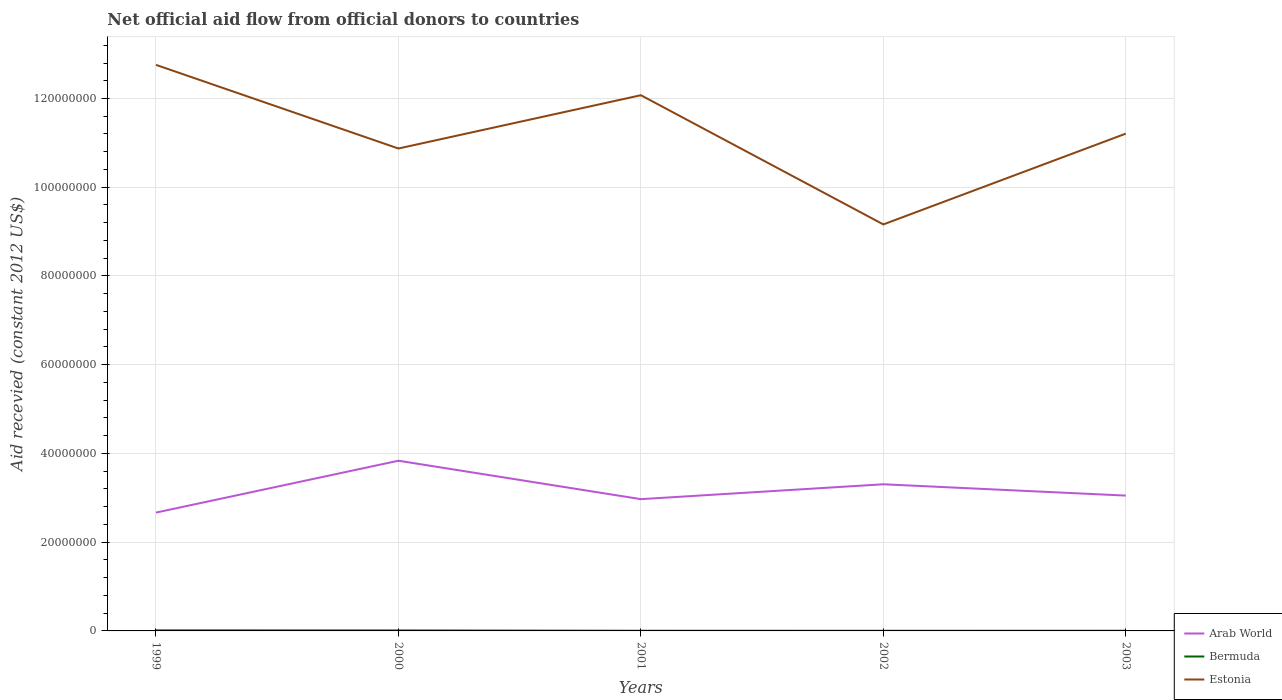Does the line corresponding to Estonia intersect with the line corresponding to Arab World?
Your answer should be very brief. No. Across all years, what is the maximum total aid received in Estonia?
Your answer should be compact. 9.16e+07. In which year was the total aid received in Bermuda maximum?
Offer a terse response. 2002. What is the total total aid received in Estonia in the graph?
Offer a terse response. 2.91e+07. What is the difference between the highest and the second highest total aid received in Estonia?
Offer a terse response. 3.60e+07. Is the total aid received in Arab World strictly greater than the total aid received in Estonia over the years?
Make the answer very short. Yes. How many lines are there?
Offer a very short reply. 3. How many years are there in the graph?
Give a very brief answer. 5. What is the difference between two consecutive major ticks on the Y-axis?
Give a very brief answer. 2.00e+07. Does the graph contain any zero values?
Offer a terse response. No. Does the graph contain grids?
Give a very brief answer. Yes. Where does the legend appear in the graph?
Keep it short and to the point. Bottom right. How many legend labels are there?
Give a very brief answer. 3. What is the title of the graph?
Your answer should be compact. Net official aid flow from official donors to countries. What is the label or title of the X-axis?
Your answer should be compact. Years. What is the label or title of the Y-axis?
Your response must be concise. Aid recevied (constant 2012 US$). What is the Aid recevied (constant 2012 US$) in Arab World in 1999?
Keep it short and to the point. 2.67e+07. What is the Aid recevied (constant 2012 US$) in Bermuda in 1999?
Offer a terse response. 1.30e+05. What is the Aid recevied (constant 2012 US$) in Estonia in 1999?
Offer a very short reply. 1.28e+08. What is the Aid recevied (constant 2012 US$) in Arab World in 2000?
Provide a succinct answer. 3.84e+07. What is the Aid recevied (constant 2012 US$) of Bermuda in 2000?
Make the answer very short. 1.10e+05. What is the Aid recevied (constant 2012 US$) in Estonia in 2000?
Your answer should be compact. 1.09e+08. What is the Aid recevied (constant 2012 US$) in Arab World in 2001?
Offer a terse response. 2.97e+07. What is the Aid recevied (constant 2012 US$) of Bermuda in 2001?
Provide a succinct answer. 4.00e+04. What is the Aid recevied (constant 2012 US$) in Estonia in 2001?
Ensure brevity in your answer.  1.21e+08. What is the Aid recevied (constant 2012 US$) of Arab World in 2002?
Offer a terse response. 3.30e+07. What is the Aid recevied (constant 2012 US$) of Estonia in 2002?
Your response must be concise. 9.16e+07. What is the Aid recevied (constant 2012 US$) in Arab World in 2003?
Provide a short and direct response. 3.05e+07. What is the Aid recevied (constant 2012 US$) of Bermuda in 2003?
Give a very brief answer. 4.00e+04. What is the Aid recevied (constant 2012 US$) in Estonia in 2003?
Provide a short and direct response. 1.12e+08. Across all years, what is the maximum Aid recevied (constant 2012 US$) of Arab World?
Provide a succinct answer. 3.84e+07. Across all years, what is the maximum Aid recevied (constant 2012 US$) in Estonia?
Keep it short and to the point. 1.28e+08. Across all years, what is the minimum Aid recevied (constant 2012 US$) of Arab World?
Ensure brevity in your answer.  2.67e+07. Across all years, what is the minimum Aid recevied (constant 2012 US$) in Bermuda?
Your response must be concise. 3.00e+04. Across all years, what is the minimum Aid recevied (constant 2012 US$) of Estonia?
Make the answer very short. 9.16e+07. What is the total Aid recevied (constant 2012 US$) of Arab World in the graph?
Keep it short and to the point. 1.58e+08. What is the total Aid recevied (constant 2012 US$) of Bermuda in the graph?
Ensure brevity in your answer.  3.50e+05. What is the total Aid recevied (constant 2012 US$) in Estonia in the graph?
Offer a terse response. 5.61e+08. What is the difference between the Aid recevied (constant 2012 US$) in Arab World in 1999 and that in 2000?
Provide a succinct answer. -1.17e+07. What is the difference between the Aid recevied (constant 2012 US$) of Bermuda in 1999 and that in 2000?
Give a very brief answer. 2.00e+04. What is the difference between the Aid recevied (constant 2012 US$) in Estonia in 1999 and that in 2000?
Your response must be concise. 1.88e+07. What is the difference between the Aid recevied (constant 2012 US$) of Arab World in 1999 and that in 2001?
Provide a short and direct response. -3.03e+06. What is the difference between the Aid recevied (constant 2012 US$) in Estonia in 1999 and that in 2001?
Ensure brevity in your answer.  6.84e+06. What is the difference between the Aid recevied (constant 2012 US$) of Arab World in 1999 and that in 2002?
Provide a short and direct response. -6.38e+06. What is the difference between the Aid recevied (constant 2012 US$) in Estonia in 1999 and that in 2002?
Offer a terse response. 3.60e+07. What is the difference between the Aid recevied (constant 2012 US$) of Arab World in 1999 and that in 2003?
Keep it short and to the point. -3.83e+06. What is the difference between the Aid recevied (constant 2012 US$) in Estonia in 1999 and that in 2003?
Offer a very short reply. 1.55e+07. What is the difference between the Aid recevied (constant 2012 US$) of Arab World in 2000 and that in 2001?
Ensure brevity in your answer.  8.66e+06. What is the difference between the Aid recevied (constant 2012 US$) of Estonia in 2000 and that in 2001?
Your response must be concise. -1.20e+07. What is the difference between the Aid recevied (constant 2012 US$) of Arab World in 2000 and that in 2002?
Provide a succinct answer. 5.31e+06. What is the difference between the Aid recevied (constant 2012 US$) in Bermuda in 2000 and that in 2002?
Provide a succinct answer. 8.00e+04. What is the difference between the Aid recevied (constant 2012 US$) of Estonia in 2000 and that in 2002?
Your answer should be compact. 1.71e+07. What is the difference between the Aid recevied (constant 2012 US$) of Arab World in 2000 and that in 2003?
Ensure brevity in your answer.  7.86e+06. What is the difference between the Aid recevied (constant 2012 US$) of Bermuda in 2000 and that in 2003?
Provide a short and direct response. 7.00e+04. What is the difference between the Aid recevied (constant 2012 US$) in Estonia in 2000 and that in 2003?
Provide a succinct answer. -3.35e+06. What is the difference between the Aid recevied (constant 2012 US$) in Arab World in 2001 and that in 2002?
Give a very brief answer. -3.35e+06. What is the difference between the Aid recevied (constant 2012 US$) of Estonia in 2001 and that in 2002?
Provide a succinct answer. 2.91e+07. What is the difference between the Aid recevied (constant 2012 US$) of Arab World in 2001 and that in 2003?
Give a very brief answer. -8.00e+05. What is the difference between the Aid recevied (constant 2012 US$) of Estonia in 2001 and that in 2003?
Offer a terse response. 8.66e+06. What is the difference between the Aid recevied (constant 2012 US$) in Arab World in 2002 and that in 2003?
Give a very brief answer. 2.55e+06. What is the difference between the Aid recevied (constant 2012 US$) of Bermuda in 2002 and that in 2003?
Give a very brief answer. -10000. What is the difference between the Aid recevied (constant 2012 US$) of Estonia in 2002 and that in 2003?
Your answer should be compact. -2.05e+07. What is the difference between the Aid recevied (constant 2012 US$) in Arab World in 1999 and the Aid recevied (constant 2012 US$) in Bermuda in 2000?
Make the answer very short. 2.66e+07. What is the difference between the Aid recevied (constant 2012 US$) in Arab World in 1999 and the Aid recevied (constant 2012 US$) in Estonia in 2000?
Provide a short and direct response. -8.21e+07. What is the difference between the Aid recevied (constant 2012 US$) of Bermuda in 1999 and the Aid recevied (constant 2012 US$) of Estonia in 2000?
Make the answer very short. -1.09e+08. What is the difference between the Aid recevied (constant 2012 US$) of Arab World in 1999 and the Aid recevied (constant 2012 US$) of Bermuda in 2001?
Your response must be concise. 2.66e+07. What is the difference between the Aid recevied (constant 2012 US$) in Arab World in 1999 and the Aid recevied (constant 2012 US$) in Estonia in 2001?
Make the answer very short. -9.41e+07. What is the difference between the Aid recevied (constant 2012 US$) in Bermuda in 1999 and the Aid recevied (constant 2012 US$) in Estonia in 2001?
Your answer should be compact. -1.21e+08. What is the difference between the Aid recevied (constant 2012 US$) in Arab World in 1999 and the Aid recevied (constant 2012 US$) in Bermuda in 2002?
Provide a short and direct response. 2.66e+07. What is the difference between the Aid recevied (constant 2012 US$) in Arab World in 1999 and the Aid recevied (constant 2012 US$) in Estonia in 2002?
Your answer should be compact. -6.50e+07. What is the difference between the Aid recevied (constant 2012 US$) in Bermuda in 1999 and the Aid recevied (constant 2012 US$) in Estonia in 2002?
Offer a very short reply. -9.15e+07. What is the difference between the Aid recevied (constant 2012 US$) of Arab World in 1999 and the Aid recevied (constant 2012 US$) of Bermuda in 2003?
Offer a terse response. 2.66e+07. What is the difference between the Aid recevied (constant 2012 US$) of Arab World in 1999 and the Aid recevied (constant 2012 US$) of Estonia in 2003?
Keep it short and to the point. -8.54e+07. What is the difference between the Aid recevied (constant 2012 US$) of Bermuda in 1999 and the Aid recevied (constant 2012 US$) of Estonia in 2003?
Make the answer very short. -1.12e+08. What is the difference between the Aid recevied (constant 2012 US$) of Arab World in 2000 and the Aid recevied (constant 2012 US$) of Bermuda in 2001?
Your answer should be very brief. 3.83e+07. What is the difference between the Aid recevied (constant 2012 US$) of Arab World in 2000 and the Aid recevied (constant 2012 US$) of Estonia in 2001?
Your response must be concise. -8.24e+07. What is the difference between the Aid recevied (constant 2012 US$) in Bermuda in 2000 and the Aid recevied (constant 2012 US$) in Estonia in 2001?
Make the answer very short. -1.21e+08. What is the difference between the Aid recevied (constant 2012 US$) of Arab World in 2000 and the Aid recevied (constant 2012 US$) of Bermuda in 2002?
Give a very brief answer. 3.83e+07. What is the difference between the Aid recevied (constant 2012 US$) of Arab World in 2000 and the Aid recevied (constant 2012 US$) of Estonia in 2002?
Make the answer very short. -5.33e+07. What is the difference between the Aid recevied (constant 2012 US$) of Bermuda in 2000 and the Aid recevied (constant 2012 US$) of Estonia in 2002?
Keep it short and to the point. -9.15e+07. What is the difference between the Aid recevied (constant 2012 US$) in Arab World in 2000 and the Aid recevied (constant 2012 US$) in Bermuda in 2003?
Your answer should be very brief. 3.83e+07. What is the difference between the Aid recevied (constant 2012 US$) in Arab World in 2000 and the Aid recevied (constant 2012 US$) in Estonia in 2003?
Provide a succinct answer. -7.37e+07. What is the difference between the Aid recevied (constant 2012 US$) in Bermuda in 2000 and the Aid recevied (constant 2012 US$) in Estonia in 2003?
Ensure brevity in your answer.  -1.12e+08. What is the difference between the Aid recevied (constant 2012 US$) of Arab World in 2001 and the Aid recevied (constant 2012 US$) of Bermuda in 2002?
Give a very brief answer. 2.97e+07. What is the difference between the Aid recevied (constant 2012 US$) in Arab World in 2001 and the Aid recevied (constant 2012 US$) in Estonia in 2002?
Offer a very short reply. -6.19e+07. What is the difference between the Aid recevied (constant 2012 US$) of Bermuda in 2001 and the Aid recevied (constant 2012 US$) of Estonia in 2002?
Give a very brief answer. -9.16e+07. What is the difference between the Aid recevied (constant 2012 US$) in Arab World in 2001 and the Aid recevied (constant 2012 US$) in Bermuda in 2003?
Give a very brief answer. 2.97e+07. What is the difference between the Aid recevied (constant 2012 US$) in Arab World in 2001 and the Aid recevied (constant 2012 US$) in Estonia in 2003?
Keep it short and to the point. -8.24e+07. What is the difference between the Aid recevied (constant 2012 US$) in Bermuda in 2001 and the Aid recevied (constant 2012 US$) in Estonia in 2003?
Your answer should be very brief. -1.12e+08. What is the difference between the Aid recevied (constant 2012 US$) in Arab World in 2002 and the Aid recevied (constant 2012 US$) in Bermuda in 2003?
Provide a short and direct response. 3.30e+07. What is the difference between the Aid recevied (constant 2012 US$) of Arab World in 2002 and the Aid recevied (constant 2012 US$) of Estonia in 2003?
Provide a short and direct response. -7.90e+07. What is the difference between the Aid recevied (constant 2012 US$) in Bermuda in 2002 and the Aid recevied (constant 2012 US$) in Estonia in 2003?
Offer a very short reply. -1.12e+08. What is the average Aid recevied (constant 2012 US$) of Arab World per year?
Ensure brevity in your answer.  3.17e+07. What is the average Aid recevied (constant 2012 US$) of Estonia per year?
Offer a terse response. 1.12e+08. In the year 1999, what is the difference between the Aid recevied (constant 2012 US$) in Arab World and Aid recevied (constant 2012 US$) in Bermuda?
Offer a terse response. 2.65e+07. In the year 1999, what is the difference between the Aid recevied (constant 2012 US$) of Arab World and Aid recevied (constant 2012 US$) of Estonia?
Offer a terse response. -1.01e+08. In the year 1999, what is the difference between the Aid recevied (constant 2012 US$) of Bermuda and Aid recevied (constant 2012 US$) of Estonia?
Keep it short and to the point. -1.27e+08. In the year 2000, what is the difference between the Aid recevied (constant 2012 US$) in Arab World and Aid recevied (constant 2012 US$) in Bermuda?
Offer a very short reply. 3.82e+07. In the year 2000, what is the difference between the Aid recevied (constant 2012 US$) in Arab World and Aid recevied (constant 2012 US$) in Estonia?
Keep it short and to the point. -7.04e+07. In the year 2000, what is the difference between the Aid recevied (constant 2012 US$) of Bermuda and Aid recevied (constant 2012 US$) of Estonia?
Ensure brevity in your answer.  -1.09e+08. In the year 2001, what is the difference between the Aid recevied (constant 2012 US$) of Arab World and Aid recevied (constant 2012 US$) of Bermuda?
Your answer should be very brief. 2.97e+07. In the year 2001, what is the difference between the Aid recevied (constant 2012 US$) of Arab World and Aid recevied (constant 2012 US$) of Estonia?
Ensure brevity in your answer.  -9.10e+07. In the year 2001, what is the difference between the Aid recevied (constant 2012 US$) in Bermuda and Aid recevied (constant 2012 US$) in Estonia?
Provide a succinct answer. -1.21e+08. In the year 2002, what is the difference between the Aid recevied (constant 2012 US$) in Arab World and Aid recevied (constant 2012 US$) in Bermuda?
Your answer should be very brief. 3.30e+07. In the year 2002, what is the difference between the Aid recevied (constant 2012 US$) in Arab World and Aid recevied (constant 2012 US$) in Estonia?
Provide a short and direct response. -5.86e+07. In the year 2002, what is the difference between the Aid recevied (constant 2012 US$) in Bermuda and Aid recevied (constant 2012 US$) in Estonia?
Offer a very short reply. -9.16e+07. In the year 2003, what is the difference between the Aid recevied (constant 2012 US$) of Arab World and Aid recevied (constant 2012 US$) of Bermuda?
Your response must be concise. 3.05e+07. In the year 2003, what is the difference between the Aid recevied (constant 2012 US$) in Arab World and Aid recevied (constant 2012 US$) in Estonia?
Ensure brevity in your answer.  -8.16e+07. In the year 2003, what is the difference between the Aid recevied (constant 2012 US$) of Bermuda and Aid recevied (constant 2012 US$) of Estonia?
Ensure brevity in your answer.  -1.12e+08. What is the ratio of the Aid recevied (constant 2012 US$) in Arab World in 1999 to that in 2000?
Offer a terse response. 0.7. What is the ratio of the Aid recevied (constant 2012 US$) in Bermuda in 1999 to that in 2000?
Offer a terse response. 1.18. What is the ratio of the Aid recevied (constant 2012 US$) of Estonia in 1999 to that in 2000?
Provide a succinct answer. 1.17. What is the ratio of the Aid recevied (constant 2012 US$) of Arab World in 1999 to that in 2001?
Provide a succinct answer. 0.9. What is the ratio of the Aid recevied (constant 2012 US$) of Estonia in 1999 to that in 2001?
Give a very brief answer. 1.06. What is the ratio of the Aid recevied (constant 2012 US$) of Arab World in 1999 to that in 2002?
Provide a succinct answer. 0.81. What is the ratio of the Aid recevied (constant 2012 US$) in Bermuda in 1999 to that in 2002?
Your answer should be very brief. 4.33. What is the ratio of the Aid recevied (constant 2012 US$) of Estonia in 1999 to that in 2002?
Give a very brief answer. 1.39. What is the ratio of the Aid recevied (constant 2012 US$) in Arab World in 1999 to that in 2003?
Provide a succinct answer. 0.87. What is the ratio of the Aid recevied (constant 2012 US$) in Bermuda in 1999 to that in 2003?
Provide a succinct answer. 3.25. What is the ratio of the Aid recevied (constant 2012 US$) of Estonia in 1999 to that in 2003?
Offer a terse response. 1.14. What is the ratio of the Aid recevied (constant 2012 US$) in Arab World in 2000 to that in 2001?
Keep it short and to the point. 1.29. What is the ratio of the Aid recevied (constant 2012 US$) of Bermuda in 2000 to that in 2001?
Give a very brief answer. 2.75. What is the ratio of the Aid recevied (constant 2012 US$) of Estonia in 2000 to that in 2001?
Your answer should be very brief. 0.9. What is the ratio of the Aid recevied (constant 2012 US$) of Arab World in 2000 to that in 2002?
Offer a terse response. 1.16. What is the ratio of the Aid recevied (constant 2012 US$) of Bermuda in 2000 to that in 2002?
Your response must be concise. 3.67. What is the ratio of the Aid recevied (constant 2012 US$) in Estonia in 2000 to that in 2002?
Your response must be concise. 1.19. What is the ratio of the Aid recevied (constant 2012 US$) of Arab World in 2000 to that in 2003?
Your answer should be compact. 1.26. What is the ratio of the Aid recevied (constant 2012 US$) of Bermuda in 2000 to that in 2003?
Your response must be concise. 2.75. What is the ratio of the Aid recevied (constant 2012 US$) of Estonia in 2000 to that in 2003?
Your response must be concise. 0.97. What is the ratio of the Aid recevied (constant 2012 US$) of Arab World in 2001 to that in 2002?
Make the answer very short. 0.9. What is the ratio of the Aid recevied (constant 2012 US$) of Estonia in 2001 to that in 2002?
Keep it short and to the point. 1.32. What is the ratio of the Aid recevied (constant 2012 US$) in Arab World in 2001 to that in 2003?
Ensure brevity in your answer.  0.97. What is the ratio of the Aid recevied (constant 2012 US$) of Estonia in 2001 to that in 2003?
Keep it short and to the point. 1.08. What is the ratio of the Aid recevied (constant 2012 US$) in Arab World in 2002 to that in 2003?
Your answer should be compact. 1.08. What is the ratio of the Aid recevied (constant 2012 US$) in Bermuda in 2002 to that in 2003?
Your response must be concise. 0.75. What is the ratio of the Aid recevied (constant 2012 US$) in Estonia in 2002 to that in 2003?
Provide a short and direct response. 0.82. What is the difference between the highest and the second highest Aid recevied (constant 2012 US$) in Arab World?
Your answer should be compact. 5.31e+06. What is the difference between the highest and the second highest Aid recevied (constant 2012 US$) of Bermuda?
Make the answer very short. 2.00e+04. What is the difference between the highest and the second highest Aid recevied (constant 2012 US$) in Estonia?
Offer a terse response. 6.84e+06. What is the difference between the highest and the lowest Aid recevied (constant 2012 US$) of Arab World?
Offer a very short reply. 1.17e+07. What is the difference between the highest and the lowest Aid recevied (constant 2012 US$) of Bermuda?
Ensure brevity in your answer.  1.00e+05. What is the difference between the highest and the lowest Aid recevied (constant 2012 US$) of Estonia?
Provide a succinct answer. 3.60e+07. 